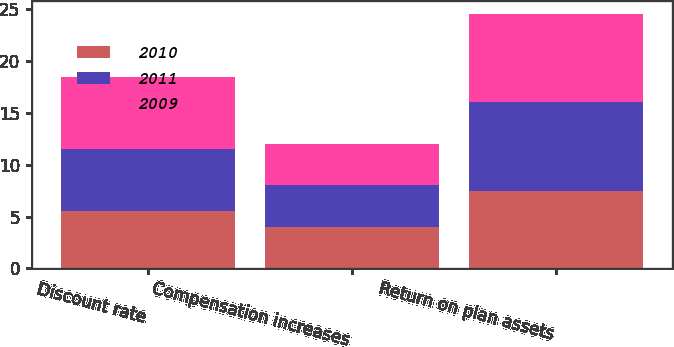Convert chart to OTSL. <chart><loc_0><loc_0><loc_500><loc_500><stacked_bar_chart><ecel><fcel>Discount rate<fcel>Compensation increases<fcel>Return on plan assets<nl><fcel>2010<fcel>5.5<fcel>4<fcel>7.5<nl><fcel>2011<fcel>6<fcel>4<fcel>8.5<nl><fcel>2009<fcel>6.94<fcel>4<fcel>8.5<nl></chart> 